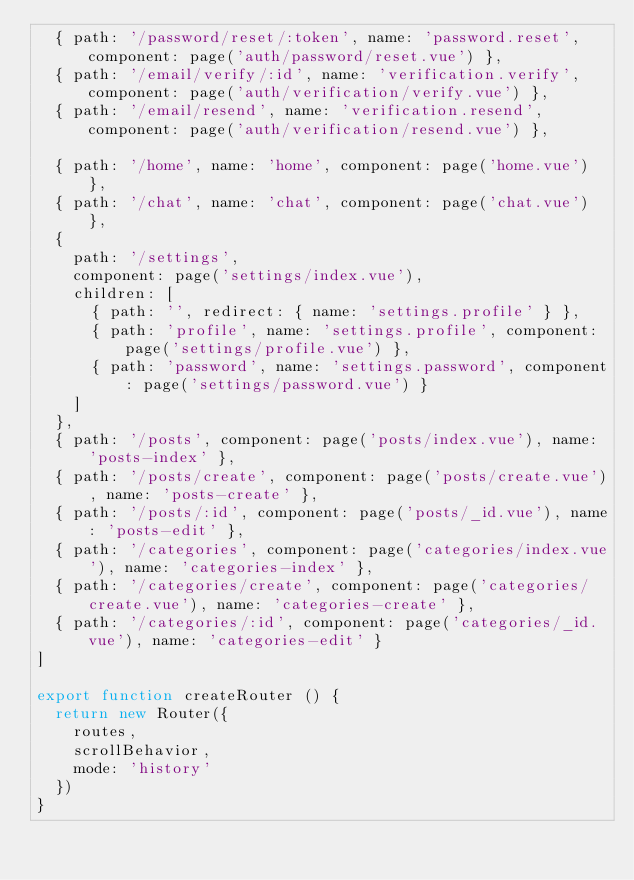Convert code to text. <code><loc_0><loc_0><loc_500><loc_500><_JavaScript_>  { path: '/password/reset/:token', name: 'password.reset', component: page('auth/password/reset.vue') },
  { path: '/email/verify/:id', name: 'verification.verify', component: page('auth/verification/verify.vue') },
  { path: '/email/resend', name: 'verification.resend', component: page('auth/verification/resend.vue') },

  { path: '/home', name: 'home', component: page('home.vue') },
  { path: '/chat', name: 'chat', component: page('chat.vue') },
  {
    path: '/settings',
    component: page('settings/index.vue'),
    children: [
      { path: '', redirect: { name: 'settings.profile' } },
      { path: 'profile', name: 'settings.profile', component: page('settings/profile.vue') },
      { path: 'password', name: 'settings.password', component: page('settings/password.vue') }
    ]
  },
  { path: '/posts', component: page('posts/index.vue'), name: 'posts-index' },
  { path: '/posts/create', component: page('posts/create.vue'), name: 'posts-create' },
  { path: '/posts/:id', component: page('posts/_id.vue'), name: 'posts-edit' },
  { path: '/categories', component: page('categories/index.vue'), name: 'categories-index' },
  { path: '/categories/create', component: page('categories/create.vue'), name: 'categories-create' },
  { path: '/categories/:id', component: page('categories/_id.vue'), name: 'categories-edit' }
]

export function createRouter () {
  return new Router({
    routes,
    scrollBehavior,
    mode: 'history'
  })
}
</code> 